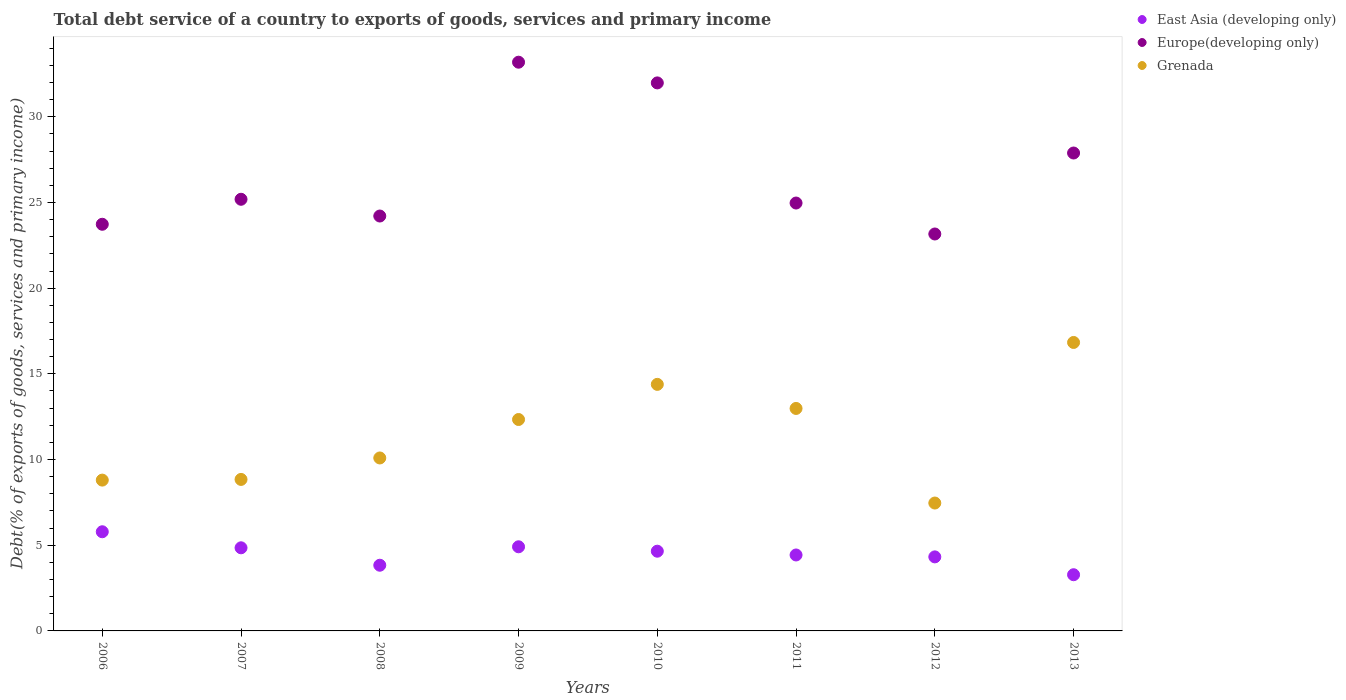Is the number of dotlines equal to the number of legend labels?
Ensure brevity in your answer.  Yes. What is the total debt service in Europe(developing only) in 2011?
Your response must be concise. 24.97. Across all years, what is the maximum total debt service in Grenada?
Provide a short and direct response. 16.83. Across all years, what is the minimum total debt service in Grenada?
Keep it short and to the point. 7.46. In which year was the total debt service in Europe(developing only) minimum?
Your answer should be very brief. 2012. What is the total total debt service in Europe(developing only) in the graph?
Give a very brief answer. 214.31. What is the difference between the total debt service in Grenada in 2009 and that in 2010?
Give a very brief answer. -2.05. What is the difference between the total debt service in Grenada in 2006 and the total debt service in Europe(developing only) in 2008?
Provide a short and direct response. -15.41. What is the average total debt service in Grenada per year?
Provide a succinct answer. 11.47. In the year 2007, what is the difference between the total debt service in East Asia (developing only) and total debt service in Europe(developing only)?
Your answer should be compact. -20.34. In how many years, is the total debt service in East Asia (developing only) greater than 19 %?
Make the answer very short. 0. What is the ratio of the total debt service in Europe(developing only) in 2012 to that in 2013?
Ensure brevity in your answer.  0.83. Is the total debt service in Grenada in 2006 less than that in 2013?
Provide a succinct answer. Yes. Is the difference between the total debt service in East Asia (developing only) in 2010 and 2011 greater than the difference between the total debt service in Europe(developing only) in 2010 and 2011?
Provide a succinct answer. No. What is the difference between the highest and the second highest total debt service in East Asia (developing only)?
Your answer should be compact. 0.88. What is the difference between the highest and the lowest total debt service in East Asia (developing only)?
Ensure brevity in your answer.  2.51. Is the sum of the total debt service in Europe(developing only) in 2011 and 2012 greater than the maximum total debt service in East Asia (developing only) across all years?
Your answer should be very brief. Yes. Is the total debt service in East Asia (developing only) strictly greater than the total debt service in Europe(developing only) over the years?
Your response must be concise. No. Is the total debt service in Grenada strictly less than the total debt service in East Asia (developing only) over the years?
Provide a short and direct response. No. What is the difference between two consecutive major ticks on the Y-axis?
Your answer should be compact. 5. Are the values on the major ticks of Y-axis written in scientific E-notation?
Offer a very short reply. No. Does the graph contain grids?
Offer a very short reply. No. How many legend labels are there?
Make the answer very short. 3. What is the title of the graph?
Offer a terse response. Total debt service of a country to exports of goods, services and primary income. What is the label or title of the Y-axis?
Your answer should be very brief. Debt(% of exports of goods, services and primary income). What is the Debt(% of exports of goods, services and primary income) in East Asia (developing only) in 2006?
Your answer should be very brief. 5.79. What is the Debt(% of exports of goods, services and primary income) of Europe(developing only) in 2006?
Offer a terse response. 23.73. What is the Debt(% of exports of goods, services and primary income) in Grenada in 2006?
Provide a succinct answer. 8.8. What is the Debt(% of exports of goods, services and primary income) of East Asia (developing only) in 2007?
Make the answer very short. 4.85. What is the Debt(% of exports of goods, services and primary income) of Europe(developing only) in 2007?
Ensure brevity in your answer.  25.19. What is the Debt(% of exports of goods, services and primary income) in Grenada in 2007?
Provide a short and direct response. 8.84. What is the Debt(% of exports of goods, services and primary income) of East Asia (developing only) in 2008?
Keep it short and to the point. 3.83. What is the Debt(% of exports of goods, services and primary income) of Europe(developing only) in 2008?
Your response must be concise. 24.21. What is the Debt(% of exports of goods, services and primary income) of Grenada in 2008?
Offer a terse response. 10.09. What is the Debt(% of exports of goods, services and primary income) of East Asia (developing only) in 2009?
Provide a short and direct response. 4.91. What is the Debt(% of exports of goods, services and primary income) in Europe(developing only) in 2009?
Your answer should be very brief. 33.19. What is the Debt(% of exports of goods, services and primary income) of Grenada in 2009?
Make the answer very short. 12.34. What is the Debt(% of exports of goods, services and primary income) of East Asia (developing only) in 2010?
Your answer should be compact. 4.65. What is the Debt(% of exports of goods, services and primary income) of Europe(developing only) in 2010?
Make the answer very short. 31.98. What is the Debt(% of exports of goods, services and primary income) of Grenada in 2010?
Ensure brevity in your answer.  14.39. What is the Debt(% of exports of goods, services and primary income) of East Asia (developing only) in 2011?
Your response must be concise. 4.43. What is the Debt(% of exports of goods, services and primary income) in Europe(developing only) in 2011?
Your response must be concise. 24.97. What is the Debt(% of exports of goods, services and primary income) of Grenada in 2011?
Your response must be concise. 12.98. What is the Debt(% of exports of goods, services and primary income) in East Asia (developing only) in 2012?
Make the answer very short. 4.32. What is the Debt(% of exports of goods, services and primary income) in Europe(developing only) in 2012?
Provide a short and direct response. 23.16. What is the Debt(% of exports of goods, services and primary income) in Grenada in 2012?
Keep it short and to the point. 7.46. What is the Debt(% of exports of goods, services and primary income) in East Asia (developing only) in 2013?
Provide a succinct answer. 3.28. What is the Debt(% of exports of goods, services and primary income) of Europe(developing only) in 2013?
Your answer should be very brief. 27.89. What is the Debt(% of exports of goods, services and primary income) of Grenada in 2013?
Your answer should be compact. 16.83. Across all years, what is the maximum Debt(% of exports of goods, services and primary income) of East Asia (developing only)?
Give a very brief answer. 5.79. Across all years, what is the maximum Debt(% of exports of goods, services and primary income) of Europe(developing only)?
Give a very brief answer. 33.19. Across all years, what is the maximum Debt(% of exports of goods, services and primary income) of Grenada?
Give a very brief answer. 16.83. Across all years, what is the minimum Debt(% of exports of goods, services and primary income) in East Asia (developing only)?
Give a very brief answer. 3.28. Across all years, what is the minimum Debt(% of exports of goods, services and primary income) in Europe(developing only)?
Your response must be concise. 23.16. Across all years, what is the minimum Debt(% of exports of goods, services and primary income) in Grenada?
Your answer should be very brief. 7.46. What is the total Debt(% of exports of goods, services and primary income) of East Asia (developing only) in the graph?
Provide a succinct answer. 36.06. What is the total Debt(% of exports of goods, services and primary income) in Europe(developing only) in the graph?
Offer a very short reply. 214.31. What is the total Debt(% of exports of goods, services and primary income) of Grenada in the graph?
Ensure brevity in your answer.  91.73. What is the difference between the Debt(% of exports of goods, services and primary income) of East Asia (developing only) in 2006 and that in 2007?
Your response must be concise. 0.94. What is the difference between the Debt(% of exports of goods, services and primary income) in Europe(developing only) in 2006 and that in 2007?
Ensure brevity in your answer.  -1.46. What is the difference between the Debt(% of exports of goods, services and primary income) of Grenada in 2006 and that in 2007?
Make the answer very short. -0.04. What is the difference between the Debt(% of exports of goods, services and primary income) of East Asia (developing only) in 2006 and that in 2008?
Offer a very short reply. 1.95. What is the difference between the Debt(% of exports of goods, services and primary income) in Europe(developing only) in 2006 and that in 2008?
Your response must be concise. -0.48. What is the difference between the Debt(% of exports of goods, services and primary income) in Grenada in 2006 and that in 2008?
Your answer should be compact. -1.29. What is the difference between the Debt(% of exports of goods, services and primary income) in East Asia (developing only) in 2006 and that in 2009?
Offer a terse response. 0.88. What is the difference between the Debt(% of exports of goods, services and primary income) of Europe(developing only) in 2006 and that in 2009?
Offer a terse response. -9.46. What is the difference between the Debt(% of exports of goods, services and primary income) of Grenada in 2006 and that in 2009?
Give a very brief answer. -3.54. What is the difference between the Debt(% of exports of goods, services and primary income) in East Asia (developing only) in 2006 and that in 2010?
Keep it short and to the point. 1.13. What is the difference between the Debt(% of exports of goods, services and primary income) in Europe(developing only) in 2006 and that in 2010?
Ensure brevity in your answer.  -8.25. What is the difference between the Debt(% of exports of goods, services and primary income) in Grenada in 2006 and that in 2010?
Give a very brief answer. -5.59. What is the difference between the Debt(% of exports of goods, services and primary income) in East Asia (developing only) in 2006 and that in 2011?
Your answer should be compact. 1.35. What is the difference between the Debt(% of exports of goods, services and primary income) of Europe(developing only) in 2006 and that in 2011?
Your answer should be very brief. -1.24. What is the difference between the Debt(% of exports of goods, services and primary income) of Grenada in 2006 and that in 2011?
Provide a short and direct response. -4.18. What is the difference between the Debt(% of exports of goods, services and primary income) in East Asia (developing only) in 2006 and that in 2012?
Keep it short and to the point. 1.47. What is the difference between the Debt(% of exports of goods, services and primary income) of Europe(developing only) in 2006 and that in 2012?
Provide a succinct answer. 0.57. What is the difference between the Debt(% of exports of goods, services and primary income) of Grenada in 2006 and that in 2012?
Provide a short and direct response. 1.34. What is the difference between the Debt(% of exports of goods, services and primary income) of East Asia (developing only) in 2006 and that in 2013?
Your response must be concise. 2.51. What is the difference between the Debt(% of exports of goods, services and primary income) in Europe(developing only) in 2006 and that in 2013?
Your answer should be compact. -4.16. What is the difference between the Debt(% of exports of goods, services and primary income) in Grenada in 2006 and that in 2013?
Provide a short and direct response. -8.03. What is the difference between the Debt(% of exports of goods, services and primary income) of East Asia (developing only) in 2007 and that in 2008?
Keep it short and to the point. 1.02. What is the difference between the Debt(% of exports of goods, services and primary income) of Europe(developing only) in 2007 and that in 2008?
Provide a succinct answer. 0.98. What is the difference between the Debt(% of exports of goods, services and primary income) of Grenada in 2007 and that in 2008?
Your response must be concise. -1.25. What is the difference between the Debt(% of exports of goods, services and primary income) of East Asia (developing only) in 2007 and that in 2009?
Ensure brevity in your answer.  -0.06. What is the difference between the Debt(% of exports of goods, services and primary income) of Europe(developing only) in 2007 and that in 2009?
Keep it short and to the point. -8. What is the difference between the Debt(% of exports of goods, services and primary income) of Grenada in 2007 and that in 2009?
Ensure brevity in your answer.  -3.5. What is the difference between the Debt(% of exports of goods, services and primary income) of East Asia (developing only) in 2007 and that in 2010?
Offer a very short reply. 0.2. What is the difference between the Debt(% of exports of goods, services and primary income) of Europe(developing only) in 2007 and that in 2010?
Ensure brevity in your answer.  -6.79. What is the difference between the Debt(% of exports of goods, services and primary income) in Grenada in 2007 and that in 2010?
Offer a very short reply. -5.55. What is the difference between the Debt(% of exports of goods, services and primary income) in East Asia (developing only) in 2007 and that in 2011?
Offer a terse response. 0.42. What is the difference between the Debt(% of exports of goods, services and primary income) of Europe(developing only) in 2007 and that in 2011?
Your answer should be compact. 0.22. What is the difference between the Debt(% of exports of goods, services and primary income) in Grenada in 2007 and that in 2011?
Make the answer very short. -4.14. What is the difference between the Debt(% of exports of goods, services and primary income) in East Asia (developing only) in 2007 and that in 2012?
Keep it short and to the point. 0.53. What is the difference between the Debt(% of exports of goods, services and primary income) of Europe(developing only) in 2007 and that in 2012?
Make the answer very short. 2.03. What is the difference between the Debt(% of exports of goods, services and primary income) of Grenada in 2007 and that in 2012?
Offer a terse response. 1.38. What is the difference between the Debt(% of exports of goods, services and primary income) of East Asia (developing only) in 2007 and that in 2013?
Provide a succinct answer. 1.57. What is the difference between the Debt(% of exports of goods, services and primary income) of Europe(developing only) in 2007 and that in 2013?
Give a very brief answer. -2.7. What is the difference between the Debt(% of exports of goods, services and primary income) in Grenada in 2007 and that in 2013?
Your response must be concise. -7.99. What is the difference between the Debt(% of exports of goods, services and primary income) of East Asia (developing only) in 2008 and that in 2009?
Give a very brief answer. -1.08. What is the difference between the Debt(% of exports of goods, services and primary income) of Europe(developing only) in 2008 and that in 2009?
Your answer should be very brief. -8.98. What is the difference between the Debt(% of exports of goods, services and primary income) of Grenada in 2008 and that in 2009?
Make the answer very short. -2.24. What is the difference between the Debt(% of exports of goods, services and primary income) in East Asia (developing only) in 2008 and that in 2010?
Offer a very short reply. -0.82. What is the difference between the Debt(% of exports of goods, services and primary income) of Europe(developing only) in 2008 and that in 2010?
Your answer should be very brief. -7.77. What is the difference between the Debt(% of exports of goods, services and primary income) in Grenada in 2008 and that in 2010?
Give a very brief answer. -4.29. What is the difference between the Debt(% of exports of goods, services and primary income) of East Asia (developing only) in 2008 and that in 2011?
Give a very brief answer. -0.6. What is the difference between the Debt(% of exports of goods, services and primary income) in Europe(developing only) in 2008 and that in 2011?
Offer a terse response. -0.76. What is the difference between the Debt(% of exports of goods, services and primary income) in Grenada in 2008 and that in 2011?
Keep it short and to the point. -2.89. What is the difference between the Debt(% of exports of goods, services and primary income) of East Asia (developing only) in 2008 and that in 2012?
Ensure brevity in your answer.  -0.49. What is the difference between the Debt(% of exports of goods, services and primary income) of Europe(developing only) in 2008 and that in 2012?
Make the answer very short. 1.05. What is the difference between the Debt(% of exports of goods, services and primary income) in Grenada in 2008 and that in 2012?
Offer a terse response. 2.63. What is the difference between the Debt(% of exports of goods, services and primary income) of East Asia (developing only) in 2008 and that in 2013?
Offer a very short reply. 0.55. What is the difference between the Debt(% of exports of goods, services and primary income) in Europe(developing only) in 2008 and that in 2013?
Your response must be concise. -3.68. What is the difference between the Debt(% of exports of goods, services and primary income) of Grenada in 2008 and that in 2013?
Provide a short and direct response. -6.74. What is the difference between the Debt(% of exports of goods, services and primary income) of East Asia (developing only) in 2009 and that in 2010?
Offer a very short reply. 0.26. What is the difference between the Debt(% of exports of goods, services and primary income) of Europe(developing only) in 2009 and that in 2010?
Offer a very short reply. 1.21. What is the difference between the Debt(% of exports of goods, services and primary income) of Grenada in 2009 and that in 2010?
Your response must be concise. -2.05. What is the difference between the Debt(% of exports of goods, services and primary income) of East Asia (developing only) in 2009 and that in 2011?
Provide a short and direct response. 0.48. What is the difference between the Debt(% of exports of goods, services and primary income) of Europe(developing only) in 2009 and that in 2011?
Offer a terse response. 8.22. What is the difference between the Debt(% of exports of goods, services and primary income) in Grenada in 2009 and that in 2011?
Your answer should be very brief. -0.65. What is the difference between the Debt(% of exports of goods, services and primary income) of East Asia (developing only) in 2009 and that in 2012?
Your answer should be very brief. 0.59. What is the difference between the Debt(% of exports of goods, services and primary income) in Europe(developing only) in 2009 and that in 2012?
Provide a succinct answer. 10.02. What is the difference between the Debt(% of exports of goods, services and primary income) of Grenada in 2009 and that in 2012?
Your answer should be compact. 4.87. What is the difference between the Debt(% of exports of goods, services and primary income) in East Asia (developing only) in 2009 and that in 2013?
Provide a short and direct response. 1.63. What is the difference between the Debt(% of exports of goods, services and primary income) of Europe(developing only) in 2009 and that in 2013?
Offer a terse response. 5.3. What is the difference between the Debt(% of exports of goods, services and primary income) of Grenada in 2009 and that in 2013?
Make the answer very short. -4.5. What is the difference between the Debt(% of exports of goods, services and primary income) in East Asia (developing only) in 2010 and that in 2011?
Offer a terse response. 0.22. What is the difference between the Debt(% of exports of goods, services and primary income) in Europe(developing only) in 2010 and that in 2011?
Your answer should be compact. 7.01. What is the difference between the Debt(% of exports of goods, services and primary income) of Grenada in 2010 and that in 2011?
Make the answer very short. 1.41. What is the difference between the Debt(% of exports of goods, services and primary income) of East Asia (developing only) in 2010 and that in 2012?
Keep it short and to the point. 0.33. What is the difference between the Debt(% of exports of goods, services and primary income) in Europe(developing only) in 2010 and that in 2012?
Give a very brief answer. 8.82. What is the difference between the Debt(% of exports of goods, services and primary income) in Grenada in 2010 and that in 2012?
Offer a terse response. 6.92. What is the difference between the Debt(% of exports of goods, services and primary income) in East Asia (developing only) in 2010 and that in 2013?
Offer a terse response. 1.37. What is the difference between the Debt(% of exports of goods, services and primary income) in Europe(developing only) in 2010 and that in 2013?
Make the answer very short. 4.09. What is the difference between the Debt(% of exports of goods, services and primary income) in Grenada in 2010 and that in 2013?
Provide a succinct answer. -2.45. What is the difference between the Debt(% of exports of goods, services and primary income) in East Asia (developing only) in 2011 and that in 2012?
Give a very brief answer. 0.11. What is the difference between the Debt(% of exports of goods, services and primary income) of Europe(developing only) in 2011 and that in 2012?
Offer a terse response. 1.81. What is the difference between the Debt(% of exports of goods, services and primary income) of Grenada in 2011 and that in 2012?
Give a very brief answer. 5.52. What is the difference between the Debt(% of exports of goods, services and primary income) of East Asia (developing only) in 2011 and that in 2013?
Provide a short and direct response. 1.15. What is the difference between the Debt(% of exports of goods, services and primary income) of Europe(developing only) in 2011 and that in 2013?
Offer a very short reply. -2.92. What is the difference between the Debt(% of exports of goods, services and primary income) of Grenada in 2011 and that in 2013?
Ensure brevity in your answer.  -3.85. What is the difference between the Debt(% of exports of goods, services and primary income) in East Asia (developing only) in 2012 and that in 2013?
Provide a short and direct response. 1.04. What is the difference between the Debt(% of exports of goods, services and primary income) of Europe(developing only) in 2012 and that in 2013?
Offer a very short reply. -4.73. What is the difference between the Debt(% of exports of goods, services and primary income) in Grenada in 2012 and that in 2013?
Make the answer very short. -9.37. What is the difference between the Debt(% of exports of goods, services and primary income) of East Asia (developing only) in 2006 and the Debt(% of exports of goods, services and primary income) of Europe(developing only) in 2007?
Give a very brief answer. -19.4. What is the difference between the Debt(% of exports of goods, services and primary income) of East Asia (developing only) in 2006 and the Debt(% of exports of goods, services and primary income) of Grenada in 2007?
Make the answer very short. -3.05. What is the difference between the Debt(% of exports of goods, services and primary income) of Europe(developing only) in 2006 and the Debt(% of exports of goods, services and primary income) of Grenada in 2007?
Make the answer very short. 14.89. What is the difference between the Debt(% of exports of goods, services and primary income) of East Asia (developing only) in 2006 and the Debt(% of exports of goods, services and primary income) of Europe(developing only) in 2008?
Ensure brevity in your answer.  -18.42. What is the difference between the Debt(% of exports of goods, services and primary income) of East Asia (developing only) in 2006 and the Debt(% of exports of goods, services and primary income) of Grenada in 2008?
Provide a succinct answer. -4.31. What is the difference between the Debt(% of exports of goods, services and primary income) in Europe(developing only) in 2006 and the Debt(% of exports of goods, services and primary income) in Grenada in 2008?
Provide a succinct answer. 13.64. What is the difference between the Debt(% of exports of goods, services and primary income) in East Asia (developing only) in 2006 and the Debt(% of exports of goods, services and primary income) in Europe(developing only) in 2009?
Provide a short and direct response. -27.4. What is the difference between the Debt(% of exports of goods, services and primary income) in East Asia (developing only) in 2006 and the Debt(% of exports of goods, services and primary income) in Grenada in 2009?
Keep it short and to the point. -6.55. What is the difference between the Debt(% of exports of goods, services and primary income) of Europe(developing only) in 2006 and the Debt(% of exports of goods, services and primary income) of Grenada in 2009?
Keep it short and to the point. 11.39. What is the difference between the Debt(% of exports of goods, services and primary income) of East Asia (developing only) in 2006 and the Debt(% of exports of goods, services and primary income) of Europe(developing only) in 2010?
Offer a very short reply. -26.19. What is the difference between the Debt(% of exports of goods, services and primary income) in East Asia (developing only) in 2006 and the Debt(% of exports of goods, services and primary income) in Grenada in 2010?
Your answer should be compact. -8.6. What is the difference between the Debt(% of exports of goods, services and primary income) in Europe(developing only) in 2006 and the Debt(% of exports of goods, services and primary income) in Grenada in 2010?
Make the answer very short. 9.34. What is the difference between the Debt(% of exports of goods, services and primary income) in East Asia (developing only) in 2006 and the Debt(% of exports of goods, services and primary income) in Europe(developing only) in 2011?
Offer a very short reply. -19.18. What is the difference between the Debt(% of exports of goods, services and primary income) in East Asia (developing only) in 2006 and the Debt(% of exports of goods, services and primary income) in Grenada in 2011?
Provide a short and direct response. -7.2. What is the difference between the Debt(% of exports of goods, services and primary income) in Europe(developing only) in 2006 and the Debt(% of exports of goods, services and primary income) in Grenada in 2011?
Your answer should be very brief. 10.75. What is the difference between the Debt(% of exports of goods, services and primary income) of East Asia (developing only) in 2006 and the Debt(% of exports of goods, services and primary income) of Europe(developing only) in 2012?
Provide a short and direct response. -17.38. What is the difference between the Debt(% of exports of goods, services and primary income) in East Asia (developing only) in 2006 and the Debt(% of exports of goods, services and primary income) in Grenada in 2012?
Make the answer very short. -1.68. What is the difference between the Debt(% of exports of goods, services and primary income) in Europe(developing only) in 2006 and the Debt(% of exports of goods, services and primary income) in Grenada in 2012?
Ensure brevity in your answer.  16.27. What is the difference between the Debt(% of exports of goods, services and primary income) of East Asia (developing only) in 2006 and the Debt(% of exports of goods, services and primary income) of Europe(developing only) in 2013?
Make the answer very short. -22.1. What is the difference between the Debt(% of exports of goods, services and primary income) in East Asia (developing only) in 2006 and the Debt(% of exports of goods, services and primary income) in Grenada in 2013?
Make the answer very short. -11.05. What is the difference between the Debt(% of exports of goods, services and primary income) of Europe(developing only) in 2006 and the Debt(% of exports of goods, services and primary income) of Grenada in 2013?
Your answer should be compact. 6.9. What is the difference between the Debt(% of exports of goods, services and primary income) of East Asia (developing only) in 2007 and the Debt(% of exports of goods, services and primary income) of Europe(developing only) in 2008?
Keep it short and to the point. -19.36. What is the difference between the Debt(% of exports of goods, services and primary income) of East Asia (developing only) in 2007 and the Debt(% of exports of goods, services and primary income) of Grenada in 2008?
Offer a very short reply. -5.24. What is the difference between the Debt(% of exports of goods, services and primary income) in Europe(developing only) in 2007 and the Debt(% of exports of goods, services and primary income) in Grenada in 2008?
Provide a succinct answer. 15.1. What is the difference between the Debt(% of exports of goods, services and primary income) in East Asia (developing only) in 2007 and the Debt(% of exports of goods, services and primary income) in Europe(developing only) in 2009?
Offer a terse response. -28.34. What is the difference between the Debt(% of exports of goods, services and primary income) of East Asia (developing only) in 2007 and the Debt(% of exports of goods, services and primary income) of Grenada in 2009?
Provide a succinct answer. -7.49. What is the difference between the Debt(% of exports of goods, services and primary income) in Europe(developing only) in 2007 and the Debt(% of exports of goods, services and primary income) in Grenada in 2009?
Your answer should be compact. 12.85. What is the difference between the Debt(% of exports of goods, services and primary income) of East Asia (developing only) in 2007 and the Debt(% of exports of goods, services and primary income) of Europe(developing only) in 2010?
Your answer should be compact. -27.13. What is the difference between the Debt(% of exports of goods, services and primary income) of East Asia (developing only) in 2007 and the Debt(% of exports of goods, services and primary income) of Grenada in 2010?
Offer a very short reply. -9.54. What is the difference between the Debt(% of exports of goods, services and primary income) of Europe(developing only) in 2007 and the Debt(% of exports of goods, services and primary income) of Grenada in 2010?
Your response must be concise. 10.8. What is the difference between the Debt(% of exports of goods, services and primary income) in East Asia (developing only) in 2007 and the Debt(% of exports of goods, services and primary income) in Europe(developing only) in 2011?
Ensure brevity in your answer.  -20.12. What is the difference between the Debt(% of exports of goods, services and primary income) of East Asia (developing only) in 2007 and the Debt(% of exports of goods, services and primary income) of Grenada in 2011?
Keep it short and to the point. -8.13. What is the difference between the Debt(% of exports of goods, services and primary income) in Europe(developing only) in 2007 and the Debt(% of exports of goods, services and primary income) in Grenada in 2011?
Your answer should be compact. 12.21. What is the difference between the Debt(% of exports of goods, services and primary income) of East Asia (developing only) in 2007 and the Debt(% of exports of goods, services and primary income) of Europe(developing only) in 2012?
Provide a short and direct response. -18.31. What is the difference between the Debt(% of exports of goods, services and primary income) in East Asia (developing only) in 2007 and the Debt(% of exports of goods, services and primary income) in Grenada in 2012?
Make the answer very short. -2.61. What is the difference between the Debt(% of exports of goods, services and primary income) in Europe(developing only) in 2007 and the Debt(% of exports of goods, services and primary income) in Grenada in 2012?
Your answer should be very brief. 17.73. What is the difference between the Debt(% of exports of goods, services and primary income) in East Asia (developing only) in 2007 and the Debt(% of exports of goods, services and primary income) in Europe(developing only) in 2013?
Keep it short and to the point. -23.04. What is the difference between the Debt(% of exports of goods, services and primary income) in East Asia (developing only) in 2007 and the Debt(% of exports of goods, services and primary income) in Grenada in 2013?
Offer a very short reply. -11.98. What is the difference between the Debt(% of exports of goods, services and primary income) in Europe(developing only) in 2007 and the Debt(% of exports of goods, services and primary income) in Grenada in 2013?
Make the answer very short. 8.36. What is the difference between the Debt(% of exports of goods, services and primary income) of East Asia (developing only) in 2008 and the Debt(% of exports of goods, services and primary income) of Europe(developing only) in 2009?
Give a very brief answer. -29.35. What is the difference between the Debt(% of exports of goods, services and primary income) of East Asia (developing only) in 2008 and the Debt(% of exports of goods, services and primary income) of Grenada in 2009?
Keep it short and to the point. -8.5. What is the difference between the Debt(% of exports of goods, services and primary income) in Europe(developing only) in 2008 and the Debt(% of exports of goods, services and primary income) in Grenada in 2009?
Your answer should be compact. 11.87. What is the difference between the Debt(% of exports of goods, services and primary income) of East Asia (developing only) in 2008 and the Debt(% of exports of goods, services and primary income) of Europe(developing only) in 2010?
Ensure brevity in your answer.  -28.14. What is the difference between the Debt(% of exports of goods, services and primary income) in East Asia (developing only) in 2008 and the Debt(% of exports of goods, services and primary income) in Grenada in 2010?
Offer a terse response. -10.55. What is the difference between the Debt(% of exports of goods, services and primary income) of Europe(developing only) in 2008 and the Debt(% of exports of goods, services and primary income) of Grenada in 2010?
Provide a succinct answer. 9.82. What is the difference between the Debt(% of exports of goods, services and primary income) of East Asia (developing only) in 2008 and the Debt(% of exports of goods, services and primary income) of Europe(developing only) in 2011?
Your answer should be compact. -21.14. What is the difference between the Debt(% of exports of goods, services and primary income) in East Asia (developing only) in 2008 and the Debt(% of exports of goods, services and primary income) in Grenada in 2011?
Provide a short and direct response. -9.15. What is the difference between the Debt(% of exports of goods, services and primary income) of Europe(developing only) in 2008 and the Debt(% of exports of goods, services and primary income) of Grenada in 2011?
Provide a succinct answer. 11.23. What is the difference between the Debt(% of exports of goods, services and primary income) of East Asia (developing only) in 2008 and the Debt(% of exports of goods, services and primary income) of Europe(developing only) in 2012?
Make the answer very short. -19.33. What is the difference between the Debt(% of exports of goods, services and primary income) in East Asia (developing only) in 2008 and the Debt(% of exports of goods, services and primary income) in Grenada in 2012?
Make the answer very short. -3.63. What is the difference between the Debt(% of exports of goods, services and primary income) in Europe(developing only) in 2008 and the Debt(% of exports of goods, services and primary income) in Grenada in 2012?
Give a very brief answer. 16.75. What is the difference between the Debt(% of exports of goods, services and primary income) of East Asia (developing only) in 2008 and the Debt(% of exports of goods, services and primary income) of Europe(developing only) in 2013?
Provide a succinct answer. -24.05. What is the difference between the Debt(% of exports of goods, services and primary income) of East Asia (developing only) in 2008 and the Debt(% of exports of goods, services and primary income) of Grenada in 2013?
Keep it short and to the point. -13. What is the difference between the Debt(% of exports of goods, services and primary income) of Europe(developing only) in 2008 and the Debt(% of exports of goods, services and primary income) of Grenada in 2013?
Keep it short and to the point. 7.38. What is the difference between the Debt(% of exports of goods, services and primary income) in East Asia (developing only) in 2009 and the Debt(% of exports of goods, services and primary income) in Europe(developing only) in 2010?
Provide a short and direct response. -27.07. What is the difference between the Debt(% of exports of goods, services and primary income) in East Asia (developing only) in 2009 and the Debt(% of exports of goods, services and primary income) in Grenada in 2010?
Offer a very short reply. -9.48. What is the difference between the Debt(% of exports of goods, services and primary income) in Europe(developing only) in 2009 and the Debt(% of exports of goods, services and primary income) in Grenada in 2010?
Your answer should be very brief. 18.8. What is the difference between the Debt(% of exports of goods, services and primary income) in East Asia (developing only) in 2009 and the Debt(% of exports of goods, services and primary income) in Europe(developing only) in 2011?
Give a very brief answer. -20.06. What is the difference between the Debt(% of exports of goods, services and primary income) of East Asia (developing only) in 2009 and the Debt(% of exports of goods, services and primary income) of Grenada in 2011?
Provide a short and direct response. -8.07. What is the difference between the Debt(% of exports of goods, services and primary income) in Europe(developing only) in 2009 and the Debt(% of exports of goods, services and primary income) in Grenada in 2011?
Provide a short and direct response. 20.2. What is the difference between the Debt(% of exports of goods, services and primary income) of East Asia (developing only) in 2009 and the Debt(% of exports of goods, services and primary income) of Europe(developing only) in 2012?
Keep it short and to the point. -18.25. What is the difference between the Debt(% of exports of goods, services and primary income) of East Asia (developing only) in 2009 and the Debt(% of exports of goods, services and primary income) of Grenada in 2012?
Make the answer very short. -2.55. What is the difference between the Debt(% of exports of goods, services and primary income) of Europe(developing only) in 2009 and the Debt(% of exports of goods, services and primary income) of Grenada in 2012?
Ensure brevity in your answer.  25.72. What is the difference between the Debt(% of exports of goods, services and primary income) of East Asia (developing only) in 2009 and the Debt(% of exports of goods, services and primary income) of Europe(developing only) in 2013?
Give a very brief answer. -22.98. What is the difference between the Debt(% of exports of goods, services and primary income) in East Asia (developing only) in 2009 and the Debt(% of exports of goods, services and primary income) in Grenada in 2013?
Offer a terse response. -11.92. What is the difference between the Debt(% of exports of goods, services and primary income) in Europe(developing only) in 2009 and the Debt(% of exports of goods, services and primary income) in Grenada in 2013?
Your answer should be very brief. 16.35. What is the difference between the Debt(% of exports of goods, services and primary income) in East Asia (developing only) in 2010 and the Debt(% of exports of goods, services and primary income) in Europe(developing only) in 2011?
Your answer should be compact. -20.32. What is the difference between the Debt(% of exports of goods, services and primary income) in East Asia (developing only) in 2010 and the Debt(% of exports of goods, services and primary income) in Grenada in 2011?
Offer a terse response. -8.33. What is the difference between the Debt(% of exports of goods, services and primary income) of Europe(developing only) in 2010 and the Debt(% of exports of goods, services and primary income) of Grenada in 2011?
Offer a terse response. 19. What is the difference between the Debt(% of exports of goods, services and primary income) of East Asia (developing only) in 2010 and the Debt(% of exports of goods, services and primary income) of Europe(developing only) in 2012?
Give a very brief answer. -18.51. What is the difference between the Debt(% of exports of goods, services and primary income) of East Asia (developing only) in 2010 and the Debt(% of exports of goods, services and primary income) of Grenada in 2012?
Offer a very short reply. -2.81. What is the difference between the Debt(% of exports of goods, services and primary income) of Europe(developing only) in 2010 and the Debt(% of exports of goods, services and primary income) of Grenada in 2012?
Provide a succinct answer. 24.52. What is the difference between the Debt(% of exports of goods, services and primary income) in East Asia (developing only) in 2010 and the Debt(% of exports of goods, services and primary income) in Europe(developing only) in 2013?
Provide a short and direct response. -23.24. What is the difference between the Debt(% of exports of goods, services and primary income) of East Asia (developing only) in 2010 and the Debt(% of exports of goods, services and primary income) of Grenada in 2013?
Your response must be concise. -12.18. What is the difference between the Debt(% of exports of goods, services and primary income) of Europe(developing only) in 2010 and the Debt(% of exports of goods, services and primary income) of Grenada in 2013?
Offer a very short reply. 15.15. What is the difference between the Debt(% of exports of goods, services and primary income) of East Asia (developing only) in 2011 and the Debt(% of exports of goods, services and primary income) of Europe(developing only) in 2012?
Provide a succinct answer. -18.73. What is the difference between the Debt(% of exports of goods, services and primary income) in East Asia (developing only) in 2011 and the Debt(% of exports of goods, services and primary income) in Grenada in 2012?
Your response must be concise. -3.03. What is the difference between the Debt(% of exports of goods, services and primary income) of Europe(developing only) in 2011 and the Debt(% of exports of goods, services and primary income) of Grenada in 2012?
Offer a terse response. 17.51. What is the difference between the Debt(% of exports of goods, services and primary income) in East Asia (developing only) in 2011 and the Debt(% of exports of goods, services and primary income) in Europe(developing only) in 2013?
Your response must be concise. -23.46. What is the difference between the Debt(% of exports of goods, services and primary income) in East Asia (developing only) in 2011 and the Debt(% of exports of goods, services and primary income) in Grenada in 2013?
Your response must be concise. -12.4. What is the difference between the Debt(% of exports of goods, services and primary income) of Europe(developing only) in 2011 and the Debt(% of exports of goods, services and primary income) of Grenada in 2013?
Make the answer very short. 8.14. What is the difference between the Debt(% of exports of goods, services and primary income) in East Asia (developing only) in 2012 and the Debt(% of exports of goods, services and primary income) in Europe(developing only) in 2013?
Your answer should be compact. -23.57. What is the difference between the Debt(% of exports of goods, services and primary income) in East Asia (developing only) in 2012 and the Debt(% of exports of goods, services and primary income) in Grenada in 2013?
Give a very brief answer. -12.51. What is the difference between the Debt(% of exports of goods, services and primary income) of Europe(developing only) in 2012 and the Debt(% of exports of goods, services and primary income) of Grenada in 2013?
Provide a succinct answer. 6.33. What is the average Debt(% of exports of goods, services and primary income) of East Asia (developing only) per year?
Your answer should be very brief. 4.51. What is the average Debt(% of exports of goods, services and primary income) of Europe(developing only) per year?
Your response must be concise. 26.79. What is the average Debt(% of exports of goods, services and primary income) of Grenada per year?
Your answer should be very brief. 11.47. In the year 2006, what is the difference between the Debt(% of exports of goods, services and primary income) of East Asia (developing only) and Debt(% of exports of goods, services and primary income) of Europe(developing only)?
Your answer should be compact. -17.94. In the year 2006, what is the difference between the Debt(% of exports of goods, services and primary income) of East Asia (developing only) and Debt(% of exports of goods, services and primary income) of Grenada?
Ensure brevity in your answer.  -3.01. In the year 2006, what is the difference between the Debt(% of exports of goods, services and primary income) of Europe(developing only) and Debt(% of exports of goods, services and primary income) of Grenada?
Provide a short and direct response. 14.93. In the year 2007, what is the difference between the Debt(% of exports of goods, services and primary income) of East Asia (developing only) and Debt(% of exports of goods, services and primary income) of Europe(developing only)?
Make the answer very short. -20.34. In the year 2007, what is the difference between the Debt(% of exports of goods, services and primary income) of East Asia (developing only) and Debt(% of exports of goods, services and primary income) of Grenada?
Your answer should be very brief. -3.99. In the year 2007, what is the difference between the Debt(% of exports of goods, services and primary income) in Europe(developing only) and Debt(% of exports of goods, services and primary income) in Grenada?
Keep it short and to the point. 16.35. In the year 2008, what is the difference between the Debt(% of exports of goods, services and primary income) of East Asia (developing only) and Debt(% of exports of goods, services and primary income) of Europe(developing only)?
Provide a short and direct response. -20.38. In the year 2008, what is the difference between the Debt(% of exports of goods, services and primary income) in East Asia (developing only) and Debt(% of exports of goods, services and primary income) in Grenada?
Your response must be concise. -6.26. In the year 2008, what is the difference between the Debt(% of exports of goods, services and primary income) in Europe(developing only) and Debt(% of exports of goods, services and primary income) in Grenada?
Keep it short and to the point. 14.12. In the year 2009, what is the difference between the Debt(% of exports of goods, services and primary income) of East Asia (developing only) and Debt(% of exports of goods, services and primary income) of Europe(developing only)?
Make the answer very short. -28.28. In the year 2009, what is the difference between the Debt(% of exports of goods, services and primary income) of East Asia (developing only) and Debt(% of exports of goods, services and primary income) of Grenada?
Offer a terse response. -7.43. In the year 2009, what is the difference between the Debt(% of exports of goods, services and primary income) of Europe(developing only) and Debt(% of exports of goods, services and primary income) of Grenada?
Keep it short and to the point. 20.85. In the year 2010, what is the difference between the Debt(% of exports of goods, services and primary income) of East Asia (developing only) and Debt(% of exports of goods, services and primary income) of Europe(developing only)?
Your response must be concise. -27.33. In the year 2010, what is the difference between the Debt(% of exports of goods, services and primary income) in East Asia (developing only) and Debt(% of exports of goods, services and primary income) in Grenada?
Your response must be concise. -9.74. In the year 2010, what is the difference between the Debt(% of exports of goods, services and primary income) of Europe(developing only) and Debt(% of exports of goods, services and primary income) of Grenada?
Give a very brief answer. 17.59. In the year 2011, what is the difference between the Debt(% of exports of goods, services and primary income) of East Asia (developing only) and Debt(% of exports of goods, services and primary income) of Europe(developing only)?
Give a very brief answer. -20.54. In the year 2011, what is the difference between the Debt(% of exports of goods, services and primary income) in East Asia (developing only) and Debt(% of exports of goods, services and primary income) in Grenada?
Your answer should be very brief. -8.55. In the year 2011, what is the difference between the Debt(% of exports of goods, services and primary income) of Europe(developing only) and Debt(% of exports of goods, services and primary income) of Grenada?
Your answer should be very brief. 11.99. In the year 2012, what is the difference between the Debt(% of exports of goods, services and primary income) of East Asia (developing only) and Debt(% of exports of goods, services and primary income) of Europe(developing only)?
Make the answer very short. -18.84. In the year 2012, what is the difference between the Debt(% of exports of goods, services and primary income) of East Asia (developing only) and Debt(% of exports of goods, services and primary income) of Grenada?
Give a very brief answer. -3.14. In the year 2012, what is the difference between the Debt(% of exports of goods, services and primary income) of Europe(developing only) and Debt(% of exports of goods, services and primary income) of Grenada?
Make the answer very short. 15.7. In the year 2013, what is the difference between the Debt(% of exports of goods, services and primary income) in East Asia (developing only) and Debt(% of exports of goods, services and primary income) in Europe(developing only)?
Keep it short and to the point. -24.61. In the year 2013, what is the difference between the Debt(% of exports of goods, services and primary income) of East Asia (developing only) and Debt(% of exports of goods, services and primary income) of Grenada?
Offer a terse response. -13.55. In the year 2013, what is the difference between the Debt(% of exports of goods, services and primary income) of Europe(developing only) and Debt(% of exports of goods, services and primary income) of Grenada?
Make the answer very short. 11.05. What is the ratio of the Debt(% of exports of goods, services and primary income) of East Asia (developing only) in 2006 to that in 2007?
Give a very brief answer. 1.19. What is the ratio of the Debt(% of exports of goods, services and primary income) in Europe(developing only) in 2006 to that in 2007?
Your response must be concise. 0.94. What is the ratio of the Debt(% of exports of goods, services and primary income) in Grenada in 2006 to that in 2007?
Offer a very short reply. 1. What is the ratio of the Debt(% of exports of goods, services and primary income) of East Asia (developing only) in 2006 to that in 2008?
Make the answer very short. 1.51. What is the ratio of the Debt(% of exports of goods, services and primary income) in Europe(developing only) in 2006 to that in 2008?
Your response must be concise. 0.98. What is the ratio of the Debt(% of exports of goods, services and primary income) in Grenada in 2006 to that in 2008?
Offer a terse response. 0.87. What is the ratio of the Debt(% of exports of goods, services and primary income) of East Asia (developing only) in 2006 to that in 2009?
Offer a very short reply. 1.18. What is the ratio of the Debt(% of exports of goods, services and primary income) in Europe(developing only) in 2006 to that in 2009?
Provide a short and direct response. 0.71. What is the ratio of the Debt(% of exports of goods, services and primary income) of Grenada in 2006 to that in 2009?
Provide a succinct answer. 0.71. What is the ratio of the Debt(% of exports of goods, services and primary income) in East Asia (developing only) in 2006 to that in 2010?
Your response must be concise. 1.24. What is the ratio of the Debt(% of exports of goods, services and primary income) in Europe(developing only) in 2006 to that in 2010?
Your response must be concise. 0.74. What is the ratio of the Debt(% of exports of goods, services and primary income) of Grenada in 2006 to that in 2010?
Ensure brevity in your answer.  0.61. What is the ratio of the Debt(% of exports of goods, services and primary income) of East Asia (developing only) in 2006 to that in 2011?
Offer a very short reply. 1.31. What is the ratio of the Debt(% of exports of goods, services and primary income) of Europe(developing only) in 2006 to that in 2011?
Provide a succinct answer. 0.95. What is the ratio of the Debt(% of exports of goods, services and primary income) of Grenada in 2006 to that in 2011?
Make the answer very short. 0.68. What is the ratio of the Debt(% of exports of goods, services and primary income) of East Asia (developing only) in 2006 to that in 2012?
Make the answer very short. 1.34. What is the ratio of the Debt(% of exports of goods, services and primary income) of Europe(developing only) in 2006 to that in 2012?
Offer a very short reply. 1.02. What is the ratio of the Debt(% of exports of goods, services and primary income) of Grenada in 2006 to that in 2012?
Offer a very short reply. 1.18. What is the ratio of the Debt(% of exports of goods, services and primary income) of East Asia (developing only) in 2006 to that in 2013?
Provide a succinct answer. 1.76. What is the ratio of the Debt(% of exports of goods, services and primary income) of Europe(developing only) in 2006 to that in 2013?
Offer a very short reply. 0.85. What is the ratio of the Debt(% of exports of goods, services and primary income) in Grenada in 2006 to that in 2013?
Provide a succinct answer. 0.52. What is the ratio of the Debt(% of exports of goods, services and primary income) of East Asia (developing only) in 2007 to that in 2008?
Give a very brief answer. 1.27. What is the ratio of the Debt(% of exports of goods, services and primary income) of Europe(developing only) in 2007 to that in 2008?
Give a very brief answer. 1.04. What is the ratio of the Debt(% of exports of goods, services and primary income) of Grenada in 2007 to that in 2008?
Your response must be concise. 0.88. What is the ratio of the Debt(% of exports of goods, services and primary income) in East Asia (developing only) in 2007 to that in 2009?
Make the answer very short. 0.99. What is the ratio of the Debt(% of exports of goods, services and primary income) of Europe(developing only) in 2007 to that in 2009?
Make the answer very short. 0.76. What is the ratio of the Debt(% of exports of goods, services and primary income) of Grenada in 2007 to that in 2009?
Offer a terse response. 0.72. What is the ratio of the Debt(% of exports of goods, services and primary income) in East Asia (developing only) in 2007 to that in 2010?
Provide a short and direct response. 1.04. What is the ratio of the Debt(% of exports of goods, services and primary income) of Europe(developing only) in 2007 to that in 2010?
Your response must be concise. 0.79. What is the ratio of the Debt(% of exports of goods, services and primary income) in Grenada in 2007 to that in 2010?
Make the answer very short. 0.61. What is the ratio of the Debt(% of exports of goods, services and primary income) of East Asia (developing only) in 2007 to that in 2011?
Your response must be concise. 1.09. What is the ratio of the Debt(% of exports of goods, services and primary income) of Europe(developing only) in 2007 to that in 2011?
Your answer should be very brief. 1.01. What is the ratio of the Debt(% of exports of goods, services and primary income) in Grenada in 2007 to that in 2011?
Your answer should be compact. 0.68. What is the ratio of the Debt(% of exports of goods, services and primary income) in East Asia (developing only) in 2007 to that in 2012?
Offer a terse response. 1.12. What is the ratio of the Debt(% of exports of goods, services and primary income) in Europe(developing only) in 2007 to that in 2012?
Offer a terse response. 1.09. What is the ratio of the Debt(% of exports of goods, services and primary income) of Grenada in 2007 to that in 2012?
Provide a succinct answer. 1.18. What is the ratio of the Debt(% of exports of goods, services and primary income) of East Asia (developing only) in 2007 to that in 2013?
Keep it short and to the point. 1.48. What is the ratio of the Debt(% of exports of goods, services and primary income) in Europe(developing only) in 2007 to that in 2013?
Give a very brief answer. 0.9. What is the ratio of the Debt(% of exports of goods, services and primary income) of Grenada in 2007 to that in 2013?
Provide a succinct answer. 0.53. What is the ratio of the Debt(% of exports of goods, services and primary income) in East Asia (developing only) in 2008 to that in 2009?
Your answer should be very brief. 0.78. What is the ratio of the Debt(% of exports of goods, services and primary income) in Europe(developing only) in 2008 to that in 2009?
Offer a terse response. 0.73. What is the ratio of the Debt(% of exports of goods, services and primary income) in Grenada in 2008 to that in 2009?
Your response must be concise. 0.82. What is the ratio of the Debt(% of exports of goods, services and primary income) of East Asia (developing only) in 2008 to that in 2010?
Keep it short and to the point. 0.82. What is the ratio of the Debt(% of exports of goods, services and primary income) of Europe(developing only) in 2008 to that in 2010?
Your answer should be very brief. 0.76. What is the ratio of the Debt(% of exports of goods, services and primary income) in Grenada in 2008 to that in 2010?
Give a very brief answer. 0.7. What is the ratio of the Debt(% of exports of goods, services and primary income) of East Asia (developing only) in 2008 to that in 2011?
Keep it short and to the point. 0.86. What is the ratio of the Debt(% of exports of goods, services and primary income) of Europe(developing only) in 2008 to that in 2011?
Provide a succinct answer. 0.97. What is the ratio of the Debt(% of exports of goods, services and primary income) of Grenada in 2008 to that in 2011?
Make the answer very short. 0.78. What is the ratio of the Debt(% of exports of goods, services and primary income) in East Asia (developing only) in 2008 to that in 2012?
Keep it short and to the point. 0.89. What is the ratio of the Debt(% of exports of goods, services and primary income) of Europe(developing only) in 2008 to that in 2012?
Keep it short and to the point. 1.05. What is the ratio of the Debt(% of exports of goods, services and primary income) of Grenada in 2008 to that in 2012?
Provide a short and direct response. 1.35. What is the ratio of the Debt(% of exports of goods, services and primary income) in East Asia (developing only) in 2008 to that in 2013?
Your answer should be very brief. 1.17. What is the ratio of the Debt(% of exports of goods, services and primary income) in Europe(developing only) in 2008 to that in 2013?
Keep it short and to the point. 0.87. What is the ratio of the Debt(% of exports of goods, services and primary income) of Grenada in 2008 to that in 2013?
Give a very brief answer. 0.6. What is the ratio of the Debt(% of exports of goods, services and primary income) of East Asia (developing only) in 2009 to that in 2010?
Your answer should be compact. 1.06. What is the ratio of the Debt(% of exports of goods, services and primary income) of Europe(developing only) in 2009 to that in 2010?
Provide a succinct answer. 1.04. What is the ratio of the Debt(% of exports of goods, services and primary income) of Grenada in 2009 to that in 2010?
Give a very brief answer. 0.86. What is the ratio of the Debt(% of exports of goods, services and primary income) of East Asia (developing only) in 2009 to that in 2011?
Keep it short and to the point. 1.11. What is the ratio of the Debt(% of exports of goods, services and primary income) of Europe(developing only) in 2009 to that in 2011?
Ensure brevity in your answer.  1.33. What is the ratio of the Debt(% of exports of goods, services and primary income) in Grenada in 2009 to that in 2011?
Provide a short and direct response. 0.95. What is the ratio of the Debt(% of exports of goods, services and primary income) in East Asia (developing only) in 2009 to that in 2012?
Ensure brevity in your answer.  1.14. What is the ratio of the Debt(% of exports of goods, services and primary income) of Europe(developing only) in 2009 to that in 2012?
Offer a terse response. 1.43. What is the ratio of the Debt(% of exports of goods, services and primary income) in Grenada in 2009 to that in 2012?
Keep it short and to the point. 1.65. What is the ratio of the Debt(% of exports of goods, services and primary income) in East Asia (developing only) in 2009 to that in 2013?
Provide a short and direct response. 1.5. What is the ratio of the Debt(% of exports of goods, services and primary income) in Europe(developing only) in 2009 to that in 2013?
Your answer should be very brief. 1.19. What is the ratio of the Debt(% of exports of goods, services and primary income) in Grenada in 2009 to that in 2013?
Your response must be concise. 0.73. What is the ratio of the Debt(% of exports of goods, services and primary income) in East Asia (developing only) in 2010 to that in 2011?
Keep it short and to the point. 1.05. What is the ratio of the Debt(% of exports of goods, services and primary income) of Europe(developing only) in 2010 to that in 2011?
Give a very brief answer. 1.28. What is the ratio of the Debt(% of exports of goods, services and primary income) of Grenada in 2010 to that in 2011?
Your answer should be very brief. 1.11. What is the ratio of the Debt(% of exports of goods, services and primary income) of East Asia (developing only) in 2010 to that in 2012?
Provide a short and direct response. 1.08. What is the ratio of the Debt(% of exports of goods, services and primary income) of Europe(developing only) in 2010 to that in 2012?
Provide a short and direct response. 1.38. What is the ratio of the Debt(% of exports of goods, services and primary income) of Grenada in 2010 to that in 2012?
Your response must be concise. 1.93. What is the ratio of the Debt(% of exports of goods, services and primary income) in East Asia (developing only) in 2010 to that in 2013?
Make the answer very short. 1.42. What is the ratio of the Debt(% of exports of goods, services and primary income) in Europe(developing only) in 2010 to that in 2013?
Offer a very short reply. 1.15. What is the ratio of the Debt(% of exports of goods, services and primary income) in Grenada in 2010 to that in 2013?
Ensure brevity in your answer.  0.85. What is the ratio of the Debt(% of exports of goods, services and primary income) of East Asia (developing only) in 2011 to that in 2012?
Your answer should be compact. 1.03. What is the ratio of the Debt(% of exports of goods, services and primary income) in Europe(developing only) in 2011 to that in 2012?
Offer a very short reply. 1.08. What is the ratio of the Debt(% of exports of goods, services and primary income) of Grenada in 2011 to that in 2012?
Give a very brief answer. 1.74. What is the ratio of the Debt(% of exports of goods, services and primary income) in East Asia (developing only) in 2011 to that in 2013?
Provide a short and direct response. 1.35. What is the ratio of the Debt(% of exports of goods, services and primary income) of Europe(developing only) in 2011 to that in 2013?
Provide a succinct answer. 0.9. What is the ratio of the Debt(% of exports of goods, services and primary income) in Grenada in 2011 to that in 2013?
Provide a short and direct response. 0.77. What is the ratio of the Debt(% of exports of goods, services and primary income) in East Asia (developing only) in 2012 to that in 2013?
Give a very brief answer. 1.32. What is the ratio of the Debt(% of exports of goods, services and primary income) in Europe(developing only) in 2012 to that in 2013?
Provide a succinct answer. 0.83. What is the ratio of the Debt(% of exports of goods, services and primary income) of Grenada in 2012 to that in 2013?
Ensure brevity in your answer.  0.44. What is the difference between the highest and the second highest Debt(% of exports of goods, services and primary income) in East Asia (developing only)?
Keep it short and to the point. 0.88. What is the difference between the highest and the second highest Debt(% of exports of goods, services and primary income) of Europe(developing only)?
Provide a succinct answer. 1.21. What is the difference between the highest and the second highest Debt(% of exports of goods, services and primary income) of Grenada?
Provide a short and direct response. 2.45. What is the difference between the highest and the lowest Debt(% of exports of goods, services and primary income) in East Asia (developing only)?
Keep it short and to the point. 2.51. What is the difference between the highest and the lowest Debt(% of exports of goods, services and primary income) of Europe(developing only)?
Your answer should be very brief. 10.02. What is the difference between the highest and the lowest Debt(% of exports of goods, services and primary income) in Grenada?
Provide a succinct answer. 9.37. 